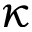<formula> <loc_0><loc_0><loc_500><loc_500>\kappa</formula> 